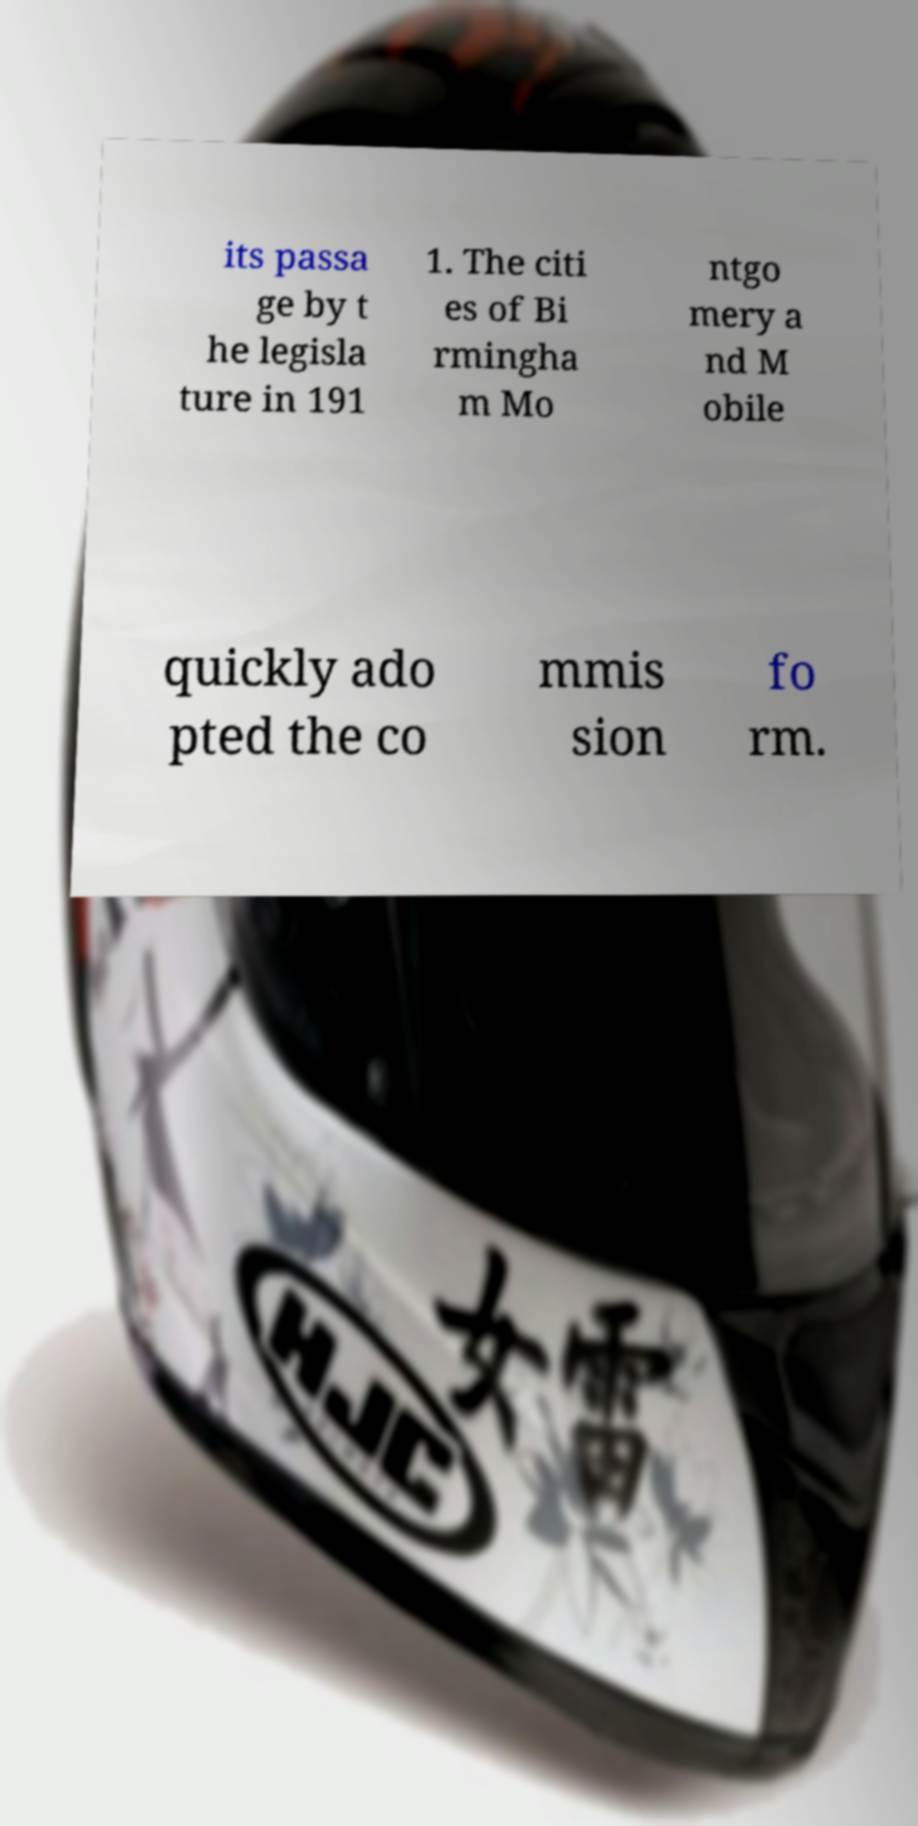I need the written content from this picture converted into text. Can you do that? its passa ge by t he legisla ture in 191 1. The citi es of Bi rmingha m Mo ntgo mery a nd M obile quickly ado pted the co mmis sion fo rm. 